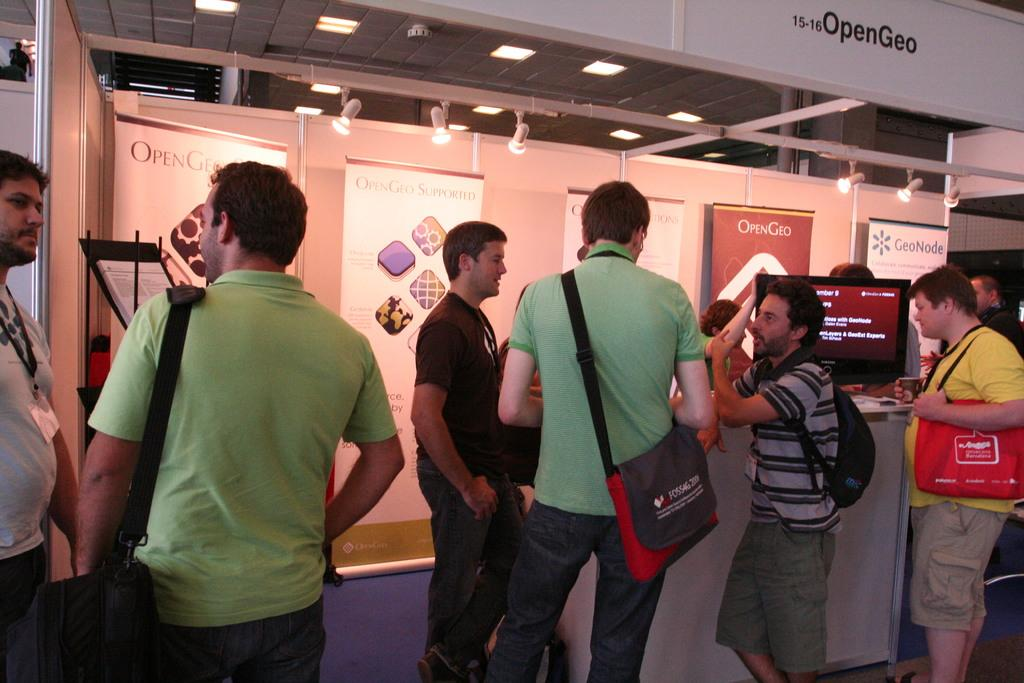How many people are present in the image? There are many people in the image. What are some of the people doing in the image? Some people are carrying bags. What can be seen on the platform in the image? There is a computer on the platform. What is visible on the wall in the background? There are banners on the wall in the background. What type of lighting is present in the image? There are lights on the ceiling. What type of magic is being performed by the person with the toe in the image? There is no person with a toe performing magic in the image. 